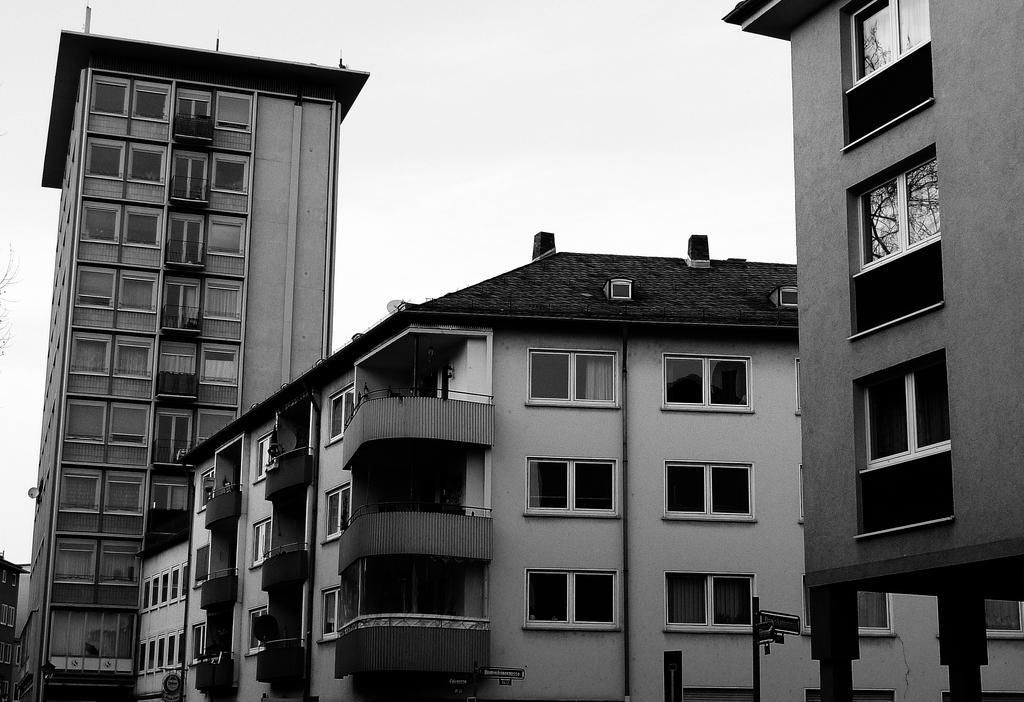Could you give a brief overview of what you see in this image? In this image there are buildings. There are glasses for windows. There is a sky. 